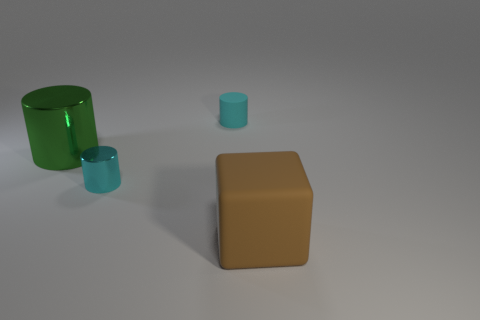Add 2 small red matte blocks. How many objects exist? 6 Subtract all cylinders. How many objects are left? 1 Subtract all brown cylinders. Subtract all cyan cylinders. How many objects are left? 2 Add 1 large metallic cylinders. How many large metallic cylinders are left? 2 Add 2 cyan things. How many cyan things exist? 4 Subtract 0 purple cylinders. How many objects are left? 4 